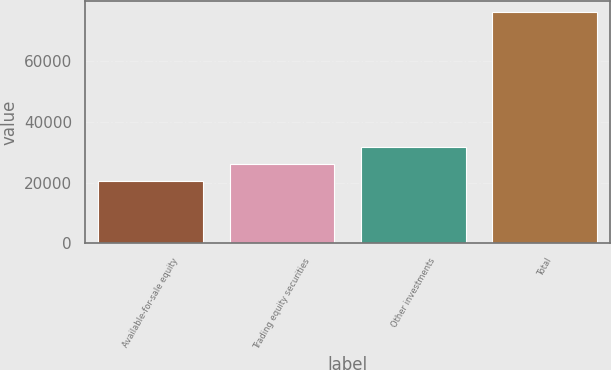<chart> <loc_0><loc_0><loc_500><loc_500><bar_chart><fcel>Available-for-sale equity<fcel>Trading equity securities<fcel>Other investments<fcel>Total<nl><fcel>20429<fcel>25975.4<fcel>31521.8<fcel>75893<nl></chart> 